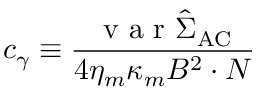<formula> <loc_0><loc_0><loc_500><loc_500>c _ { \gamma } \equiv \frac { v a r \hat { \Sigma } _ { A C } } { 4 \eta _ { m } \kappa _ { m } B ^ { 2 } \cdot N }</formula> 